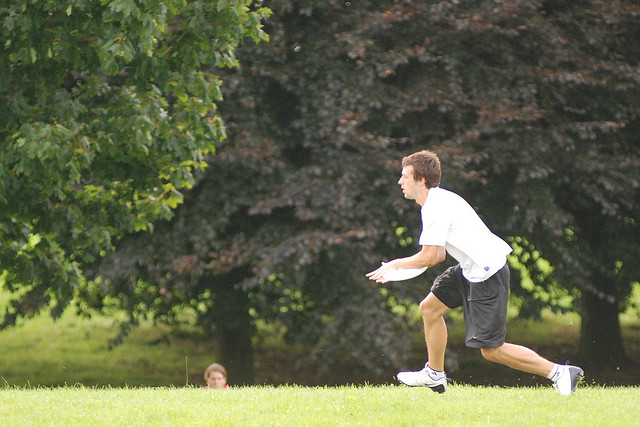What activity is the person in the foreground engaging in? The person in the foreground appears to be in the middle of a dynamic physical activity, potentially running or playing a sport such as Frisbee or football, characterized by his focused expression and the athletic posture. 